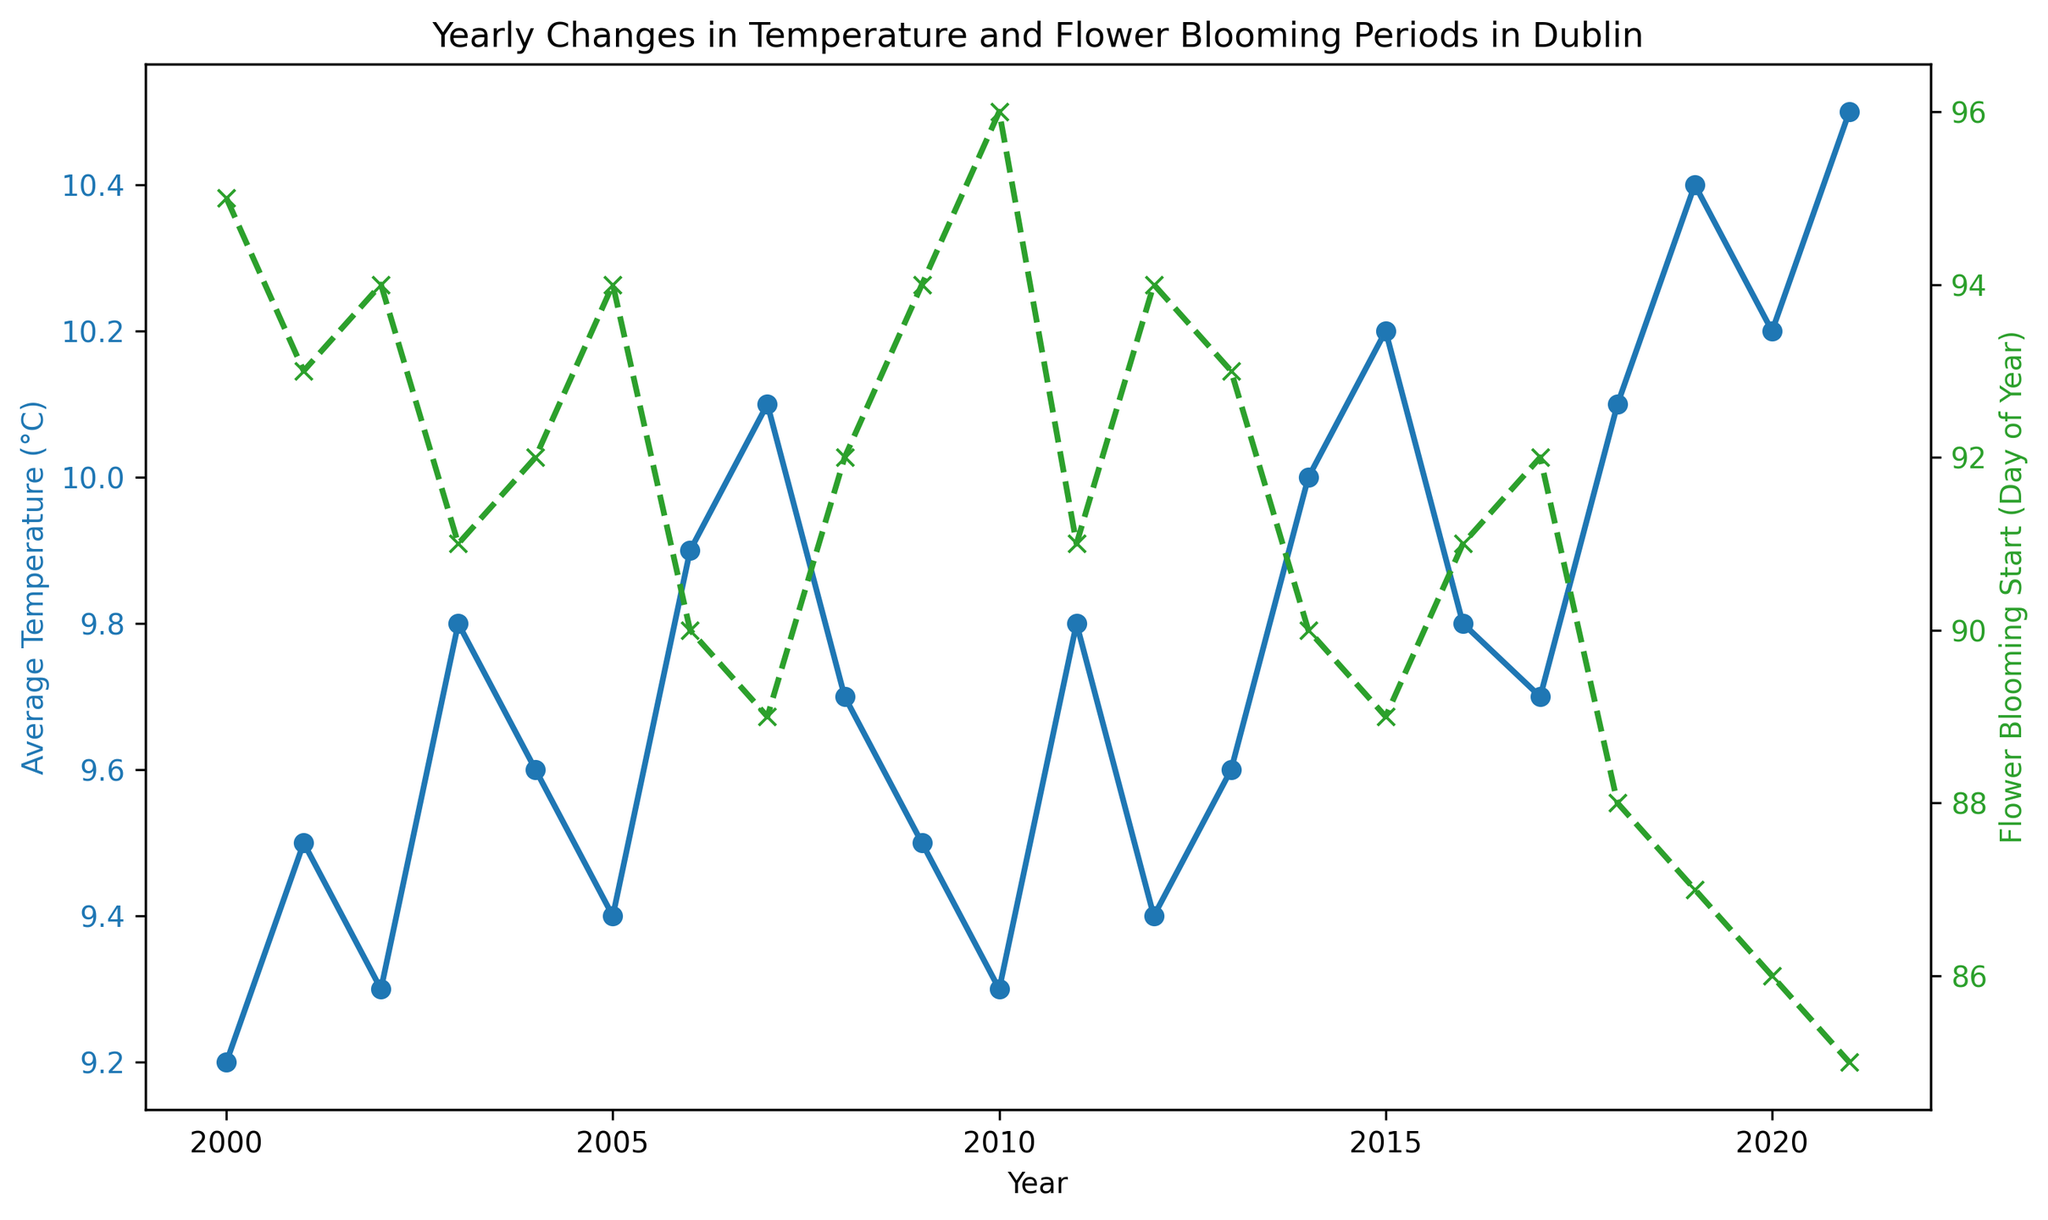Which year had the highest average temperature? The line plot for average temperature shows that the year with the highest peak is 2021.
Answer: 2021 What is the trend in the average temperature over the years? The average temperature shows a rising trend from 2000 to 2021.
Answer: Rising How many years did the flower blooming start on or before the 90th day of the year? Check the line with markers for flower blooming start and count the years where the value is 90 or less. These years are 2006, 2007, 2014, 2015, 2018, 2019, 2020, and 2021, totaling 8 years.
Answer: 8 In which year was the difference between average temperature and flower blooming start day the greatest? Calculate the absolute difference for each year and compare them. The year 2021 has the highest difference (10.5 - 85 = -74.5, taking absolute, 74.5).
Answer: 2021 Was there a year where the blooming start day increased compared to the previous year? Look for instances where the green line (flower blooming start) shows an upward movement compared to the previous year. For example, 2010 (96 from 94) and 2013 (93 from 94).
Answer: Yes What is the average flower blooming start day for the years with an average temperature above 10°C? Identify the years with average temperatures above 10°C: 2007, 2014, 2015, 2018, 2019, 2020, 2021. Add the start days and divide by the number of years (89+90+89+88+87+86+85) / 7 = 88.
Answer: 88 Which year had the earliest flower blooming period? The earliest flower blooming is marked by the lowest value on the green line, which is in the year 2021 (85th day).
Answer: 2021 Between 2000 and 2021, did the flower blooming start earlier or later as the average temperature increased? Observe the trend of the green line (flower blooming) in relation to rising temperatures; it generally moves downward, indicating earlier blooming as temperature rises.
Answer: Earlier What is the overall change in average temperature from 2000 to 2021? Subtract the average temperature of 2000 (9.2°C) from that of 2021 (10.5°C): 10.5 - 9.2 = 1.3.
Answer: 1.3°C What is the correlation between average temperature and flower blooming start days? Observe the lines: as the blue line (average temperature) increases, the green line (flower blooming start) decreases. This suggests a strong negative correlation.
Answer: Negative 